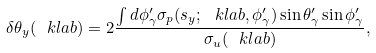<formula> <loc_0><loc_0><loc_500><loc_500>\delta \theta _ { y } ( \ k l a b ) = 2 \frac { \int d \phi _ { \gamma } ^ { \prime } \sigma _ { p } ( s _ { y } ; \ k l a b , \phi _ { \gamma } ^ { \prime } ) \sin \theta _ { \gamma } ^ { \prime } \sin \phi _ { \gamma } ^ { \prime } } { \sigma _ { u } ( \ k l a b ) } ,</formula> 